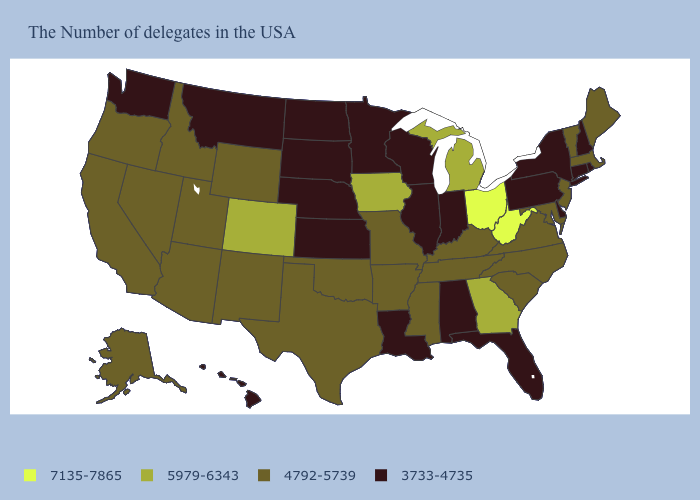What is the value of South Carolina?
Give a very brief answer. 4792-5739. Does South Dakota have a lower value than Illinois?
Write a very short answer. No. What is the value of Hawaii?
Quick response, please. 3733-4735. Among the states that border Pennsylvania , which have the lowest value?
Write a very short answer. New York, Delaware. Which states have the highest value in the USA?
Give a very brief answer. West Virginia, Ohio. What is the value of Maine?
Keep it brief. 4792-5739. Does Washington have a lower value than Mississippi?
Answer briefly. Yes. Name the states that have a value in the range 3733-4735?
Give a very brief answer. Rhode Island, New Hampshire, Connecticut, New York, Delaware, Pennsylvania, Florida, Indiana, Alabama, Wisconsin, Illinois, Louisiana, Minnesota, Kansas, Nebraska, South Dakota, North Dakota, Montana, Washington, Hawaii. Name the states that have a value in the range 4792-5739?
Short answer required. Maine, Massachusetts, Vermont, New Jersey, Maryland, Virginia, North Carolina, South Carolina, Kentucky, Tennessee, Mississippi, Missouri, Arkansas, Oklahoma, Texas, Wyoming, New Mexico, Utah, Arizona, Idaho, Nevada, California, Oregon, Alaska. What is the lowest value in the USA?
Write a very short answer. 3733-4735. Does Pennsylvania have a lower value than Utah?
Give a very brief answer. Yes. What is the lowest value in states that border Georgia?
Be succinct. 3733-4735. Name the states that have a value in the range 7135-7865?
Keep it brief. West Virginia, Ohio. Does Alaska have the lowest value in the USA?
Give a very brief answer. No. Name the states that have a value in the range 4792-5739?
Be succinct. Maine, Massachusetts, Vermont, New Jersey, Maryland, Virginia, North Carolina, South Carolina, Kentucky, Tennessee, Mississippi, Missouri, Arkansas, Oklahoma, Texas, Wyoming, New Mexico, Utah, Arizona, Idaho, Nevada, California, Oregon, Alaska. 